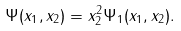Convert formula to latex. <formula><loc_0><loc_0><loc_500><loc_500>\Psi ( x _ { 1 } , x _ { 2 } ) = x _ { 2 } ^ { 2 } \Psi _ { 1 } ( x _ { 1 } , x _ { 2 } ) .</formula> 